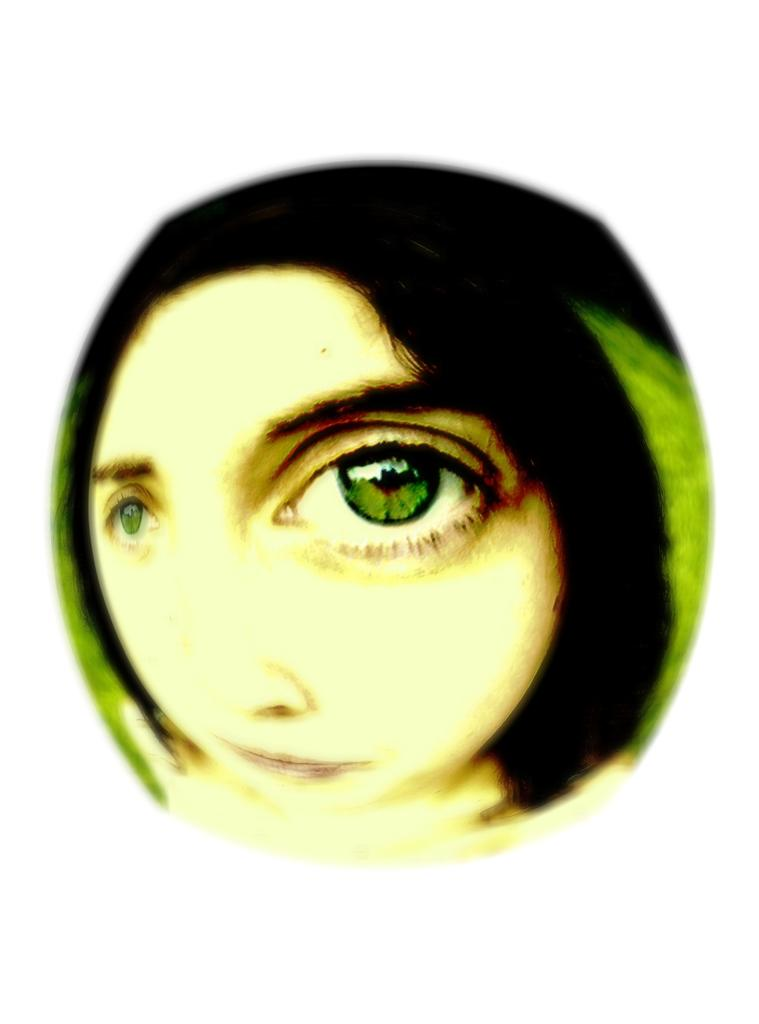What is the main subject in the center of the image? There is a person in the center of the image. What else is located in the center of the image? There is an object in the center of the image. What color is the background of the image? The background of the image is white. How many rings are visible on the person's fingers in the image? There is no information about rings or fingers in the provided facts, so we cannot determine the number of rings visible on the person's fingers in the image. 